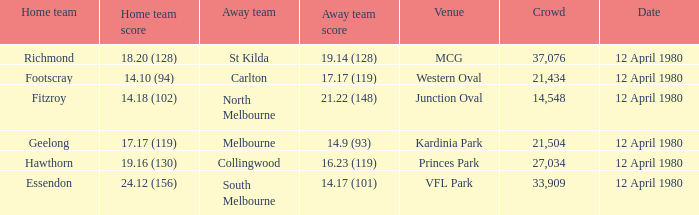Who was North Melbourne's home opponent? Fitzroy. 